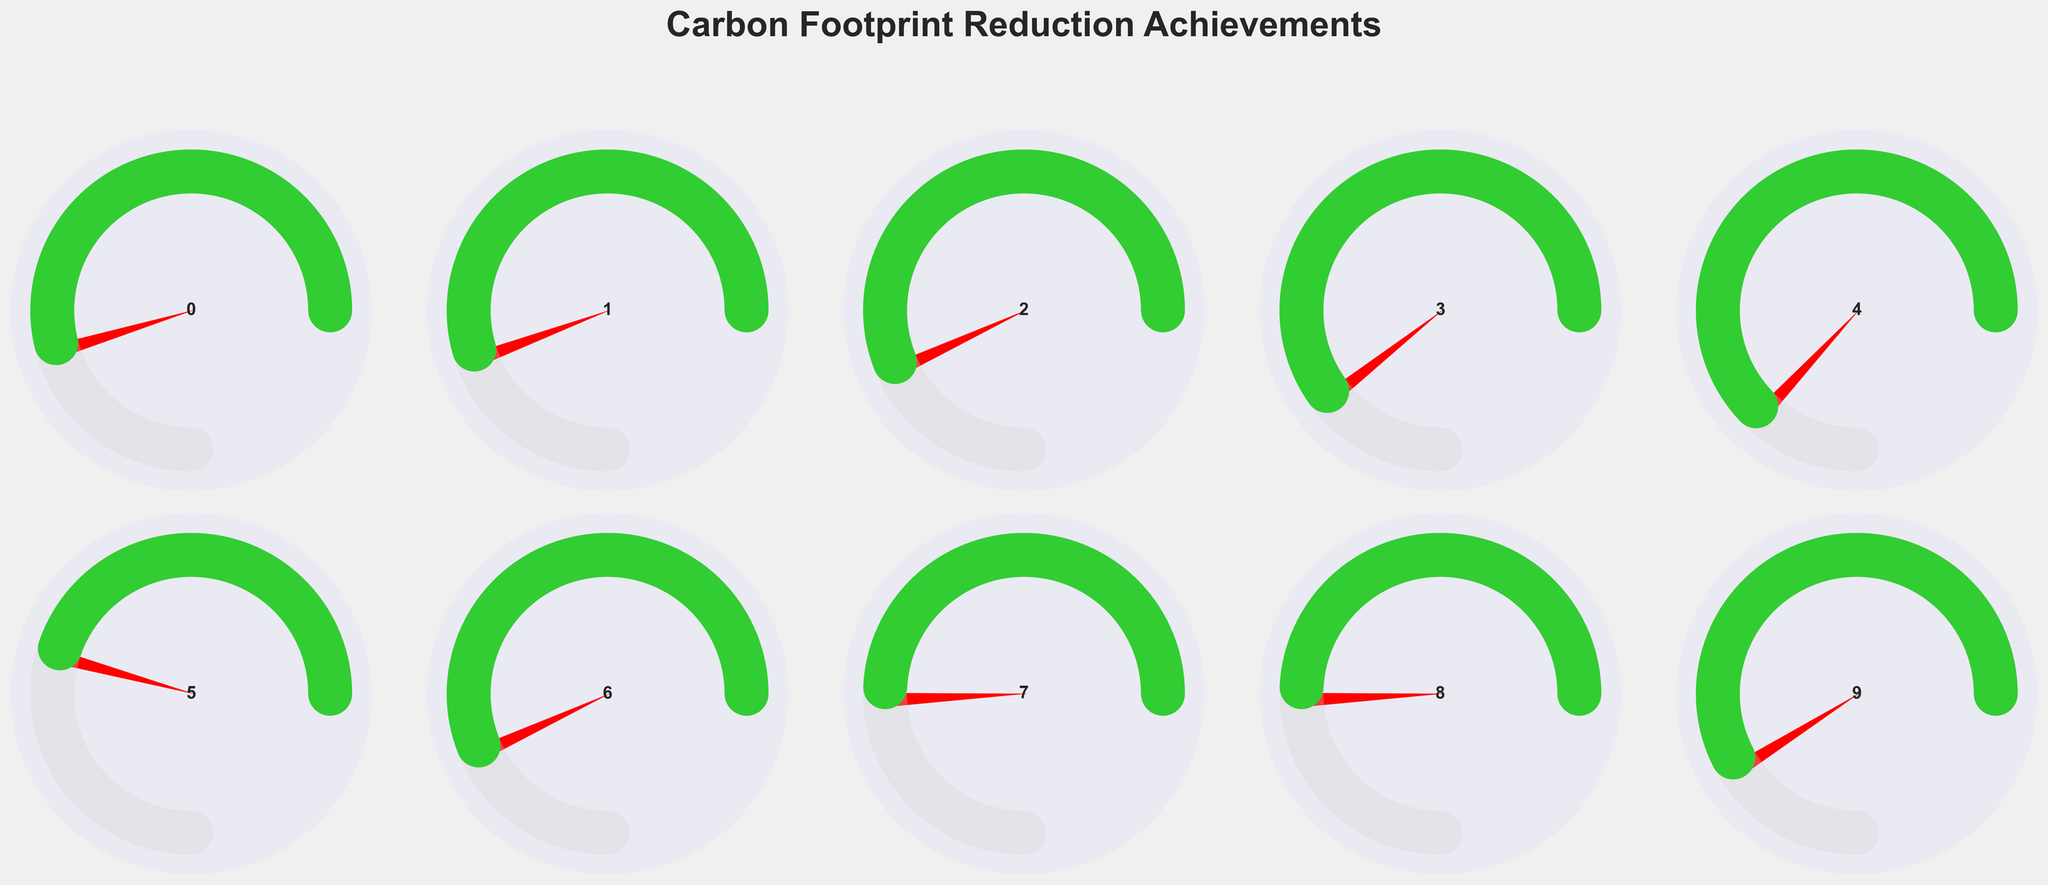What is the title of the figure? The title of the figure is typically displayed at the top of the plot and summarizes the main topic. Here, it's displayed above all gauge charts.
Answer: Carbon Footprint Reduction Achievements How many startups are represented in the figure? The figure consists of a grid with each cell displaying a gauge chart representing a startup. By counting these cells, we can find the total.
Answer: 10 Which startup has achieved the highest carbon reduction percentage? By examining the gauge charts, we look for the one with the highest percentage of carbon reduction. Redwood Materials stands out with 35%.
Answer: Redwood Materials How does Beyond Meat's achieved reduction compare to its target reduction? For Beyond Meat, we compare the green arc (achieved reduction of 28%) to the total space in the gauge (target reduction of 35%).
Answer: 28% out of 35% Which startup has the smallest percentage difference between its achieved and target reductions? Calculate the difference between the achieved and target reductions for each startup, and identify the smallest result. Climeworks has a difference of 7 percentage points (25 - 18).
Answer: Climeworks What proportion of their target has Proterra achieved? To find the proportion, we look at Proterra's gauge chart and calculate 30% of 40%. This can be expressed as 30 / 40 = 0.75 or 75%.
Answer: 75% Which startup achieved more than 20% but less than 30% in carbon reduction? By visually inspecting the gauge charts, we identify Impossible Foods with 25% and Beyond Meat with 28% falling in the specified range.
Answer: Impossible Foods and Beyond Meat What is the average target reduction of all startups? Add up all the target reductions and divide by the number of startups: (25 + 30 + 20 + 35 + 30 + 20 + 40 + 30 + 15 + 45) / 10 = 29%.
Answer: 29% Which startups have an achieved reduction of less than 20%? Look at the gauge charts to find the startups with achieved reductions below 20%. Climeworks (18%), Bolt Threads (15%), Lime (12%), Apeel Sciences (10%).
Answer: Climeworks, Bolt Threads, Lime, Apeel Sciences What is the total carbon reduction achieved by the startups achieving over 20%? Sum the percentages of startups with reductions over 20%: Northvolt (22%), Beyond Meat (28%), Impossible Foods (25%), Proterra (30%), and Redwood Materials (35%). The sum is 140%.
Answer: 140% 